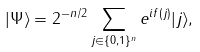Convert formula to latex. <formula><loc_0><loc_0><loc_500><loc_500>| \Psi \rangle = 2 ^ { - n / 2 } \sum _ { j \in \{ 0 , 1 \} ^ { n } } e ^ { i f ( j ) } | j \rangle ,</formula> 